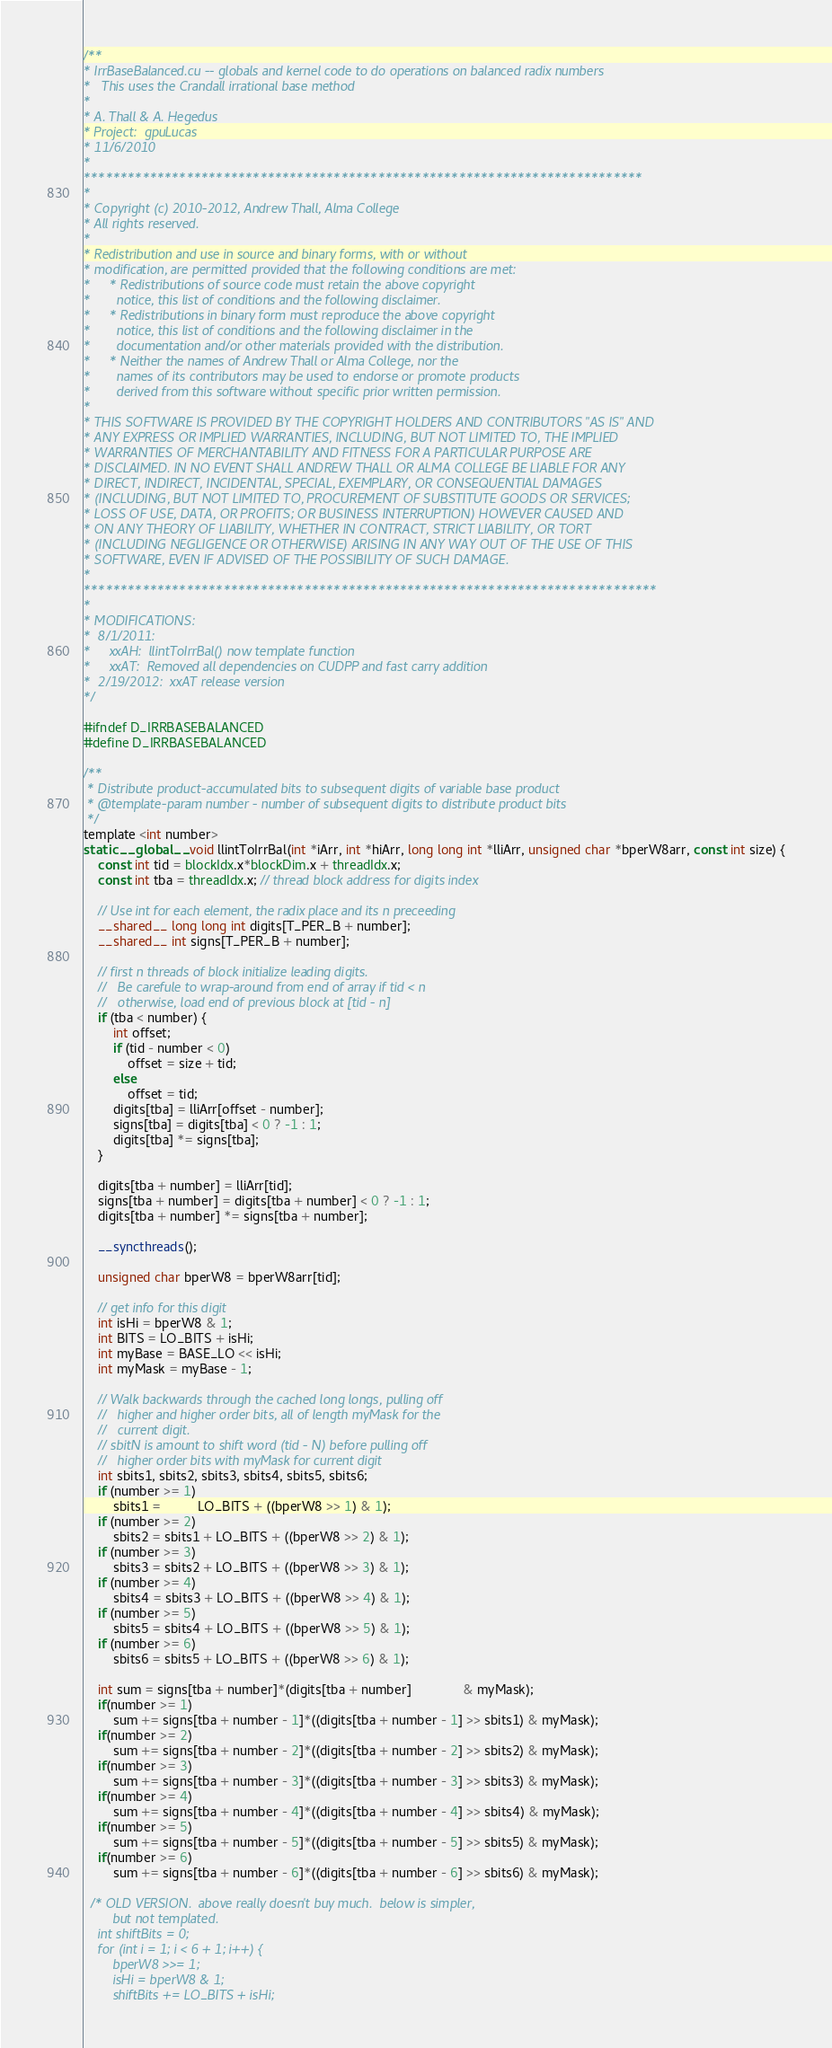Convert code to text. <code><loc_0><loc_0><loc_500><loc_500><_Cuda_>/**
* IrrBaseBalanced.cu -- globals and kernel code to do operations on balanced radix numbers
*   This uses the Crandall irrational base method
*
* A. Thall & A. Hegedus
* Project:  gpuLucas
* 11/6/2010
*
****************************************************************************
*
* Copyright (c) 2010-2012, Andrew Thall, Alma College
* All rights reserved.
*
* Redistribution and use in source and binary forms, with or without
* modification, are permitted provided that the following conditions are met:
*     * Redistributions of source code must retain the above copyright
*       notice, this list of conditions and the following disclaimer.
*     * Redistributions in binary form must reproduce the above copyright
*       notice, this list of conditions and the following disclaimer in the
*       documentation and/or other materials provided with the distribution.
*     * Neither the names of Andrew Thall or Alma College, nor the
*       names of its contributors may be used to endorse or promote products
*       derived from this software without specific prior written permission.
*
* THIS SOFTWARE IS PROVIDED BY THE COPYRIGHT HOLDERS AND CONTRIBUTORS "AS IS" AND
* ANY EXPRESS OR IMPLIED WARRANTIES, INCLUDING, BUT NOT LIMITED TO, THE IMPLIED
* WARRANTIES OF MERCHANTABILITY AND FITNESS FOR A PARTICULAR PURPOSE ARE
* DISCLAIMED. IN NO EVENT SHALL ANDREW THALL OR ALMA COLLEGE BE LIABLE FOR ANY
* DIRECT, INDIRECT, INCIDENTAL, SPECIAL, EXEMPLARY, OR CONSEQUENTIAL DAMAGES
* (INCLUDING, BUT NOT LIMITED TO, PROCUREMENT OF SUBSTITUTE GOODS OR SERVICES;
* LOSS OF USE, DATA, OR PROFITS; OR BUSINESS INTERRUPTION) HOWEVER CAUSED AND
* ON ANY THEORY OF LIABILITY, WHETHER IN CONTRACT, STRICT LIABILITY, OR TORT
* (INCLUDING NEGLIGENCE OR OTHERWISE) ARISING IN ANY WAY OUT OF THE USE OF THIS
* SOFTWARE, EVEN IF ADVISED OF THE POSSIBILITY OF SUCH DAMAGE.
*
******************************************************************************
*
* MODIFICATIONS:
*  8/1/2011:
*     xxAH:  llintToIrrBal() now template function
*     xxAT:  Removed all dependencies on CUDPP and fast carry addition
*  2/19/2012:  xxAT release version
*/

#ifndef D_IRRBASEBALANCED
#define D_IRRBASEBALANCED

/**
 * Distribute product-accumulated bits to subsequent digits of variable base product
 * @template-param number - number of subsequent digits to distribute product bits
 */
template <int number>
static __global__ void llintToIrrBal(int *iArr, int *hiArr, long long int *lliArr, unsigned char *bperW8arr, const int size) {
	const int tid = blockIdx.x*blockDim.x + threadIdx.x;
	const int tba = threadIdx.x; // thread block address for digits index

	// Use int for each element, the radix place and its n preceeding
	__shared__ long long int digits[T_PER_B + number];
	__shared__ int signs[T_PER_B + number];
	
	// first n threads of block initialize leading digits.
	//   Be carefule to wrap-around from end of array if tid < n
	//   otherwise, load end of previous block at [tid - n]
	if (tba < number) {
     	int offset;
		if (tid - number < 0) 
			offset = size + tid;
		else
			offset = tid;
		digits[tba] = lliArr[offset - number];
		signs[tba] = digits[tba] < 0 ? -1 : 1;
		digits[tba] *= signs[tba];
	}

	digits[tba + number] = lliArr[tid];
	signs[tba + number] = digits[tba + number] < 0 ? -1 : 1;
	digits[tba + number] *= signs[tba + number]; 
	
	__syncthreads();
	
	unsigned char bperW8 = bperW8arr[tid];

	// get info for this digit
	int isHi = bperW8 & 1;
	int BITS = LO_BITS + isHi;
	int myBase = BASE_LO << isHi;
	int myMask = myBase - 1;

	// Walk backwards through the cached long longs, pulling off
	//   higher and higher order bits, all of length myMask for the
	//   current digit.
	// sbitN is amount to shift word (tid - N) before pulling off
	//   higher order bits with myMask for current digit
	int sbits1, sbits2, sbits3, sbits4, sbits5, sbits6;
	if (number >= 1) 
		sbits1 =          LO_BITS + ((bperW8 >> 1) & 1);
	if (number >= 2) 
		sbits2 = sbits1 + LO_BITS + ((bperW8 >> 2) & 1);
	if (number >= 3) 
		sbits3 = sbits2 + LO_BITS + ((bperW8 >> 3) & 1);
	if (number >= 4) 
		sbits4 = sbits3 + LO_BITS + ((bperW8 >> 4) & 1);
	if (number >= 5) 
		sbits5 = sbits4 + LO_BITS + ((bperW8 >> 5) & 1);
	if (number >= 6) 
		sbits6 = sbits5 + LO_BITS + ((bperW8 >> 6) & 1);

	int sum = signs[tba + number]*(digits[tba + number]              & myMask);
	if(number >= 1)
		sum += signs[tba + number - 1]*((digits[tba + number - 1] >> sbits1) & myMask);
	if(number >= 2)
		sum += signs[tba + number - 2]*((digits[tba + number - 2] >> sbits2) & myMask);
	if(number >= 3)
		sum += signs[tba + number - 3]*((digits[tba + number - 3] >> sbits3) & myMask);
	if(number >= 4)
		sum += signs[tba + number - 4]*((digits[tba + number - 4] >> sbits4) & myMask);
	if(number >= 5)
		sum += signs[tba + number - 5]*((digits[tba + number - 5] >> sbits5) & myMask);
	if(number >= 6)
		sum += signs[tba + number - 6]*((digits[tba + number - 6] >> sbits6) & myMask);

  /* OLD VERSION.  above really doesn't buy much.  below is simpler,
        but not templated.
  	int shiftBits = 0;
	for (int i = 1; i < 6 + 1; i++) {
		bperW8 >>= 1;
		isHi = bperW8 & 1;
		shiftBits += LO_BITS + isHi;</code> 